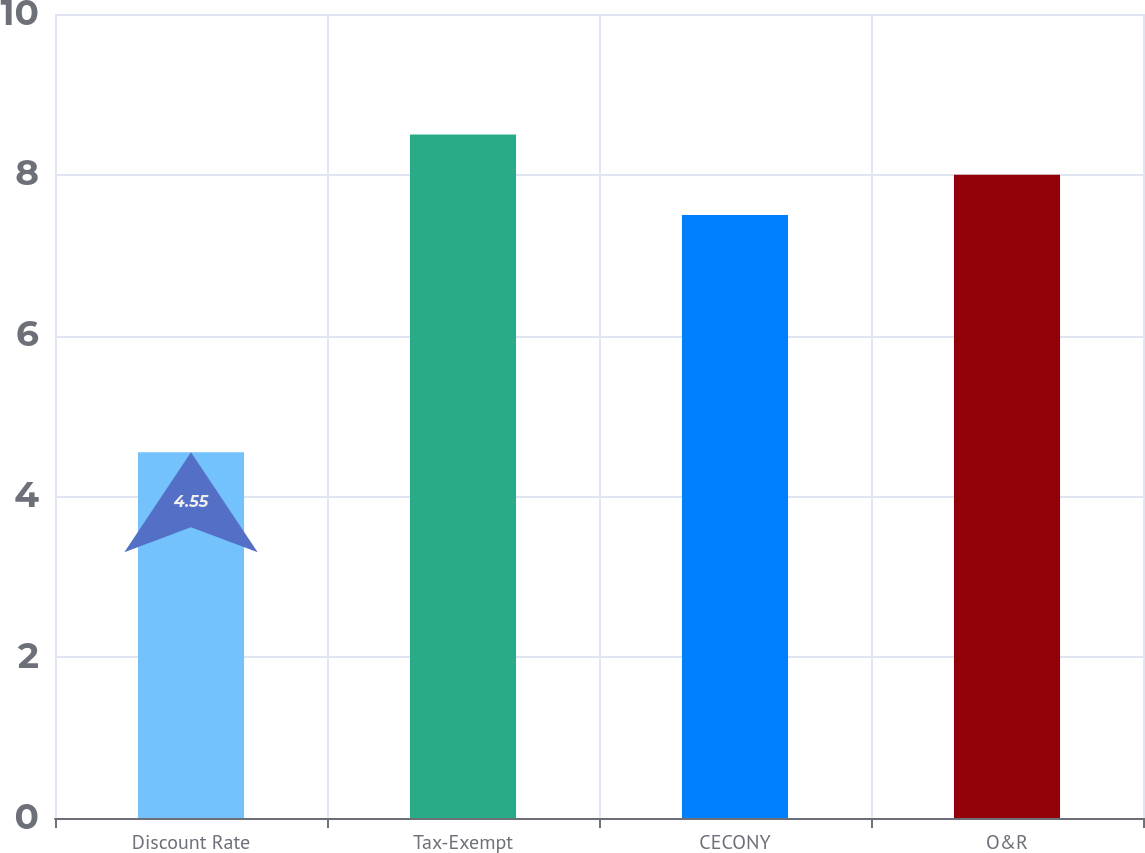Convert chart. <chart><loc_0><loc_0><loc_500><loc_500><bar_chart><fcel>Discount Rate<fcel>Tax-Exempt<fcel>CECONY<fcel>O&R<nl><fcel>4.55<fcel>8.5<fcel>7.5<fcel>8<nl></chart> 